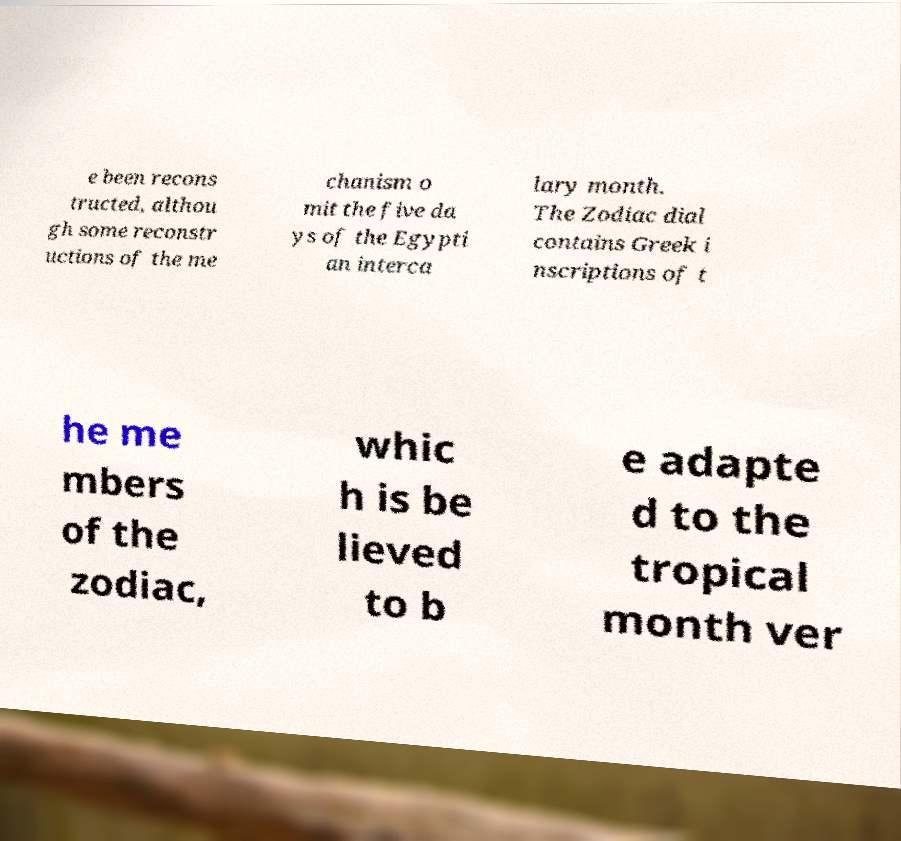Can you accurately transcribe the text from the provided image for me? e been recons tructed, althou gh some reconstr uctions of the me chanism o mit the five da ys of the Egypti an interca lary month. The Zodiac dial contains Greek i nscriptions of t he me mbers of the zodiac, whic h is be lieved to b e adapte d to the tropical month ver 